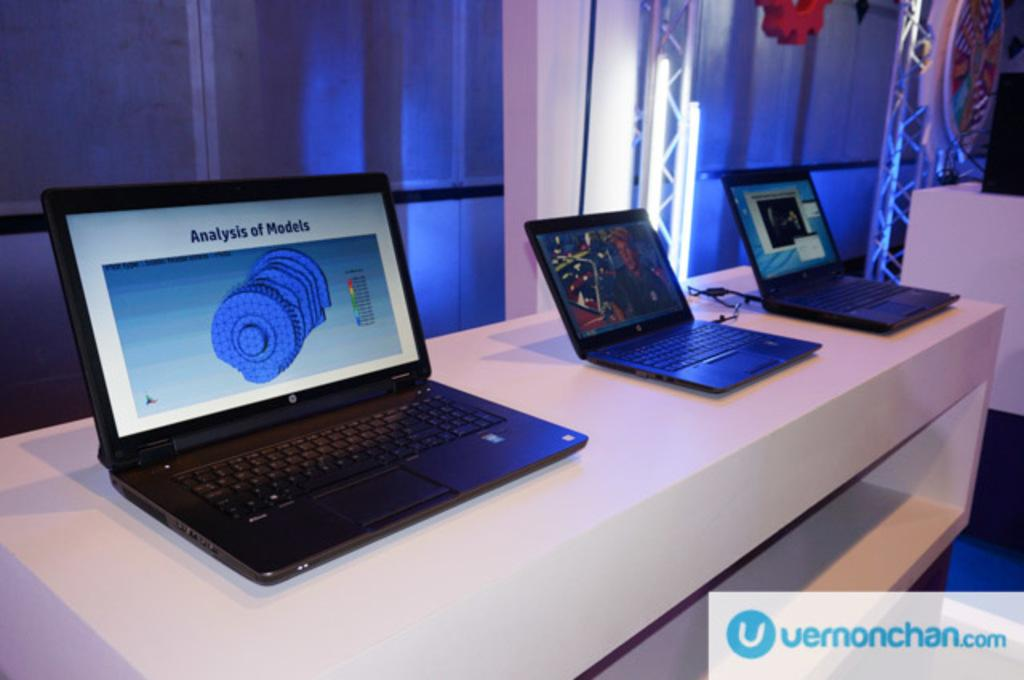<image>
Write a terse but informative summary of the picture. Three laptops are sitting on a white table and one of them has an Analysis of Models on the screen. 